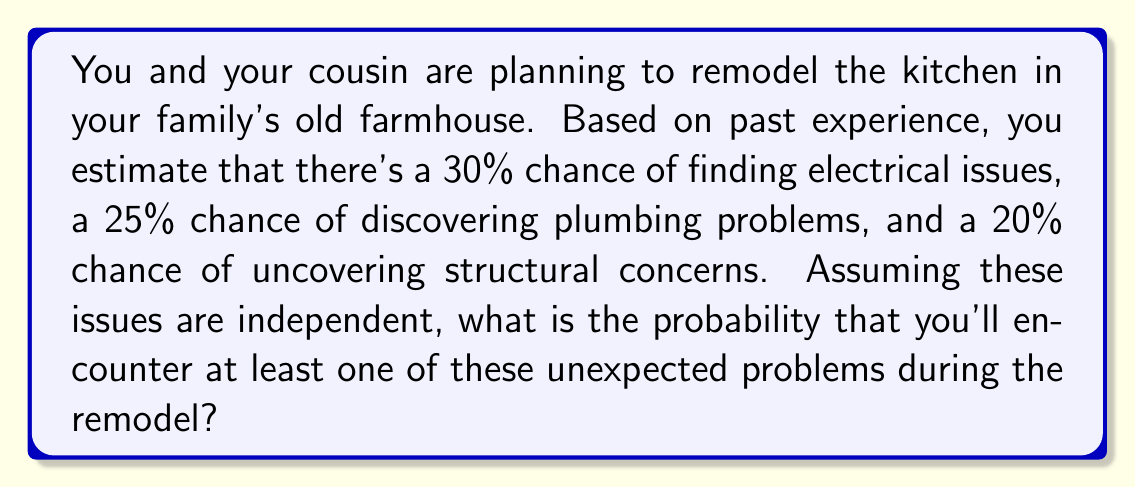Help me with this question. Let's approach this step-by-step:

1) First, let's define our events:
   E: Electrical issues
   P: Plumbing problems
   S: Structural concerns

2) We're given the following probabilities:
   $P(E) = 0.30$
   $P(P) = 0.25$
   $P(S) = 0.20$

3) We want to find the probability of at least one of these issues occurring. It's easier to calculate the probability of none of these issues occurring and then subtract that from 1.

4) The probability of no issues occurring is the product of the probabilities of each issue not occurring:

   $P(\text{no issues}) = P(\text{not E}) \times P(\text{not P}) \times P(\text{not S})$

5) We can calculate each of these:
   $P(\text{not E}) = 1 - P(E) = 1 - 0.30 = 0.70$
   $P(\text{not P}) = 1 - P(P) = 1 - 0.25 = 0.75$
   $P(\text{not S}) = 1 - P(S) = 1 - 0.20 = 0.80$

6) Now we can multiply these:
   $P(\text{no issues}) = 0.70 \times 0.75 \times 0.80 = 0.42$

7) Therefore, the probability of at least one issue occurring is:
   $P(\text{at least one issue}) = 1 - P(\text{no issues}) = 1 - 0.42 = 0.58$

8) Converting to a percentage: $0.58 \times 100\% = 58\%$
Answer: 58% 